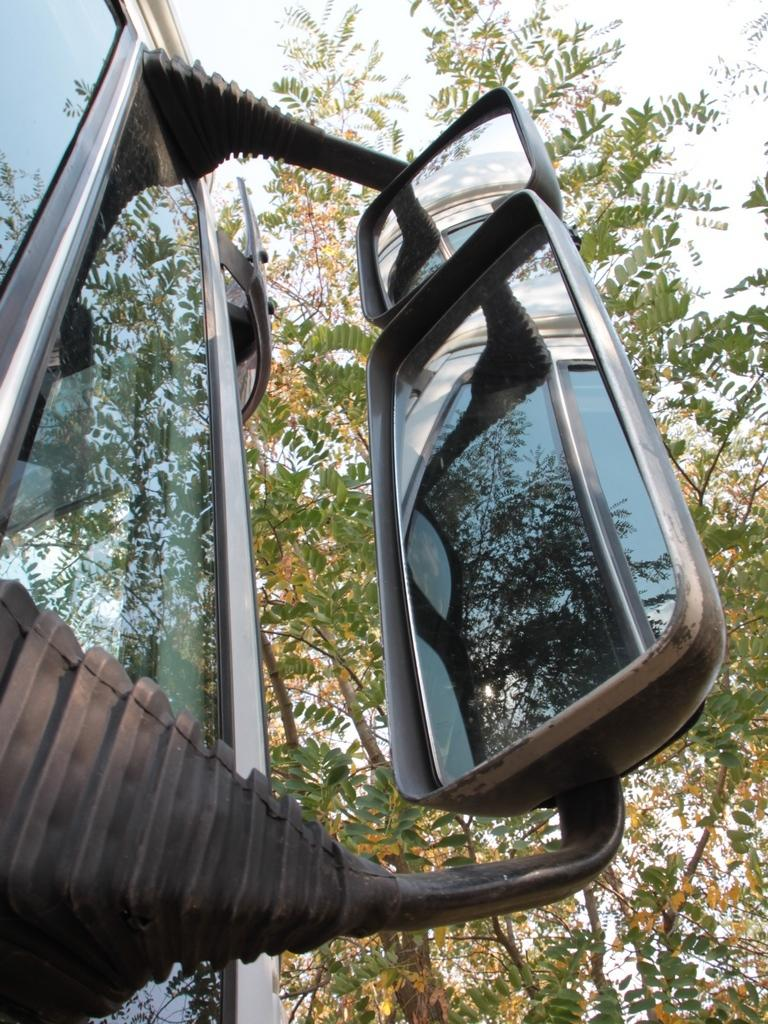What is the main object in the image that has mirrors attached to it? There are mirrors attached to a glass object in the image. What can be seen in the background of the image? There are trees and the sky visible in the background of the image. Can you tell me how many women are standing next to the glass object in the image? There is no woman present in the image; it only features a glass object with mirrors attached and the background with trees and the sky. 